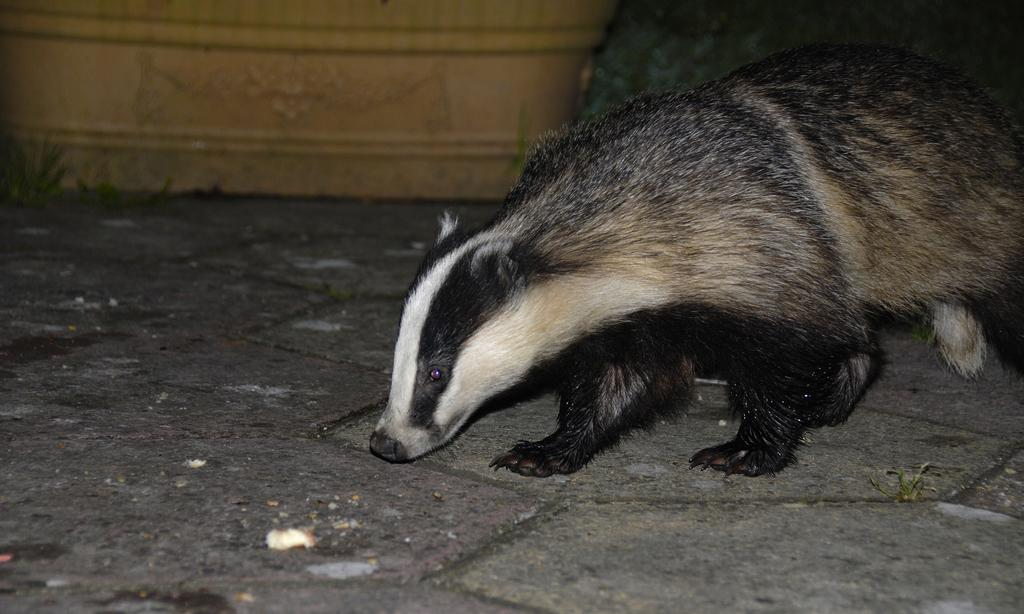What animal is present in the image? There is a badger in the image. Where is the badger located? The badger is on the land. What can be seen in the background of the image? There is a wall in the background of the image. How does the badger help with the cough in the image? There is no cough or any indication of a cough in the image, and the badger is not shown providing any assistance related to a cough. 